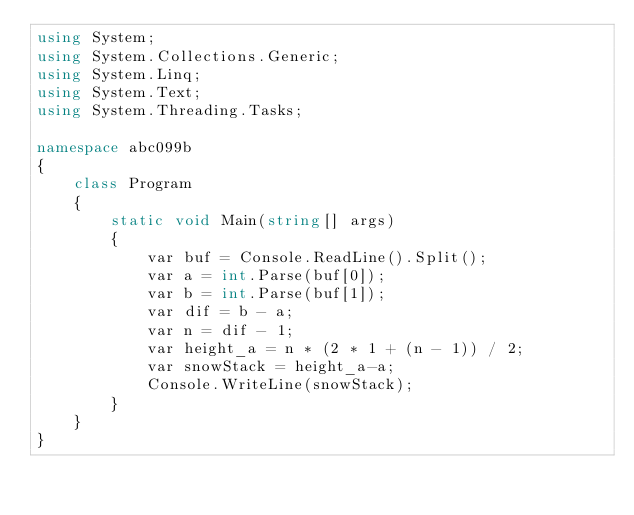<code> <loc_0><loc_0><loc_500><loc_500><_C#_>using System;
using System.Collections.Generic;
using System.Linq;
using System.Text;
using System.Threading.Tasks;

namespace abc099b
{
    class Program
    {
        static void Main(string[] args)
        {
            var buf = Console.ReadLine().Split();
            var a = int.Parse(buf[0]);
            var b = int.Parse(buf[1]);
            var dif = b - a;
            var n = dif - 1;
            var height_a = n * (2 * 1 + (n - 1)) / 2;
            var snowStack = height_a-a;
            Console.WriteLine(snowStack);
        }
    }
}
</code> 